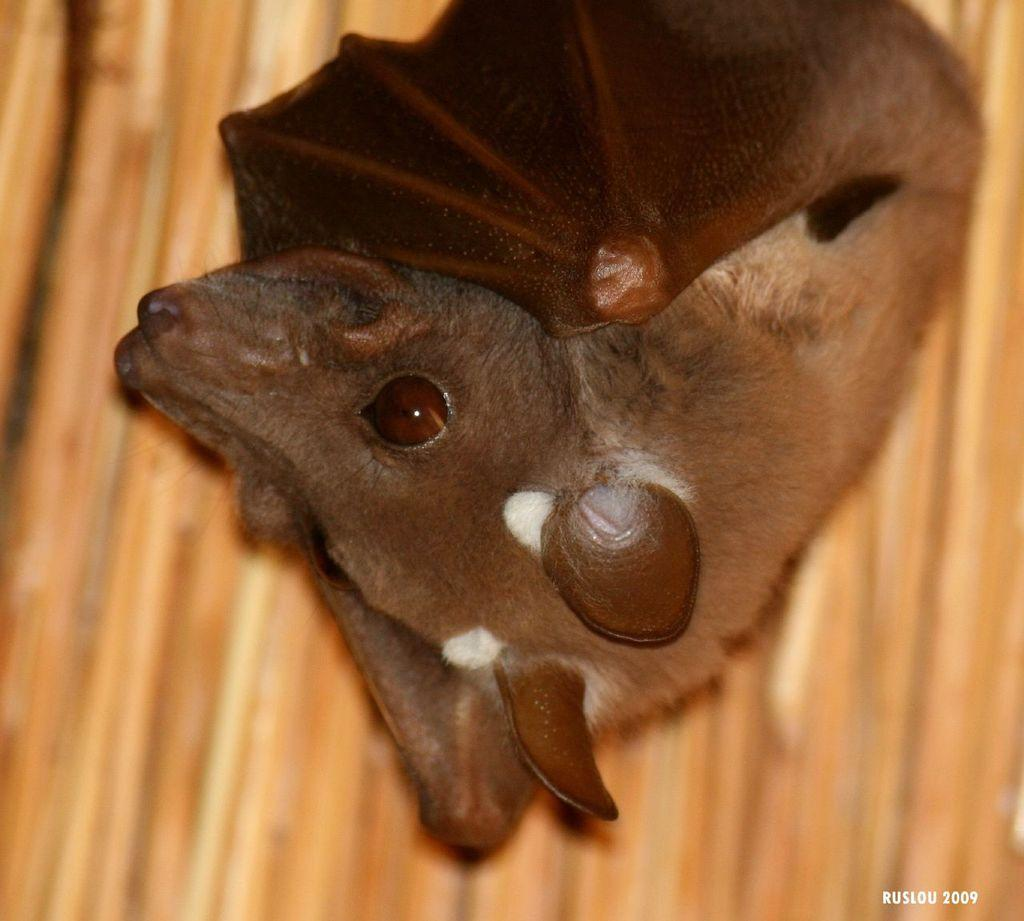What animal is present in the image? There is a bat in the image. Where is the bat located? The bat is on a surface. What color is the paint on the park bench in the image? There is no park bench or paint present in the image; it only features a bat on a surface. 